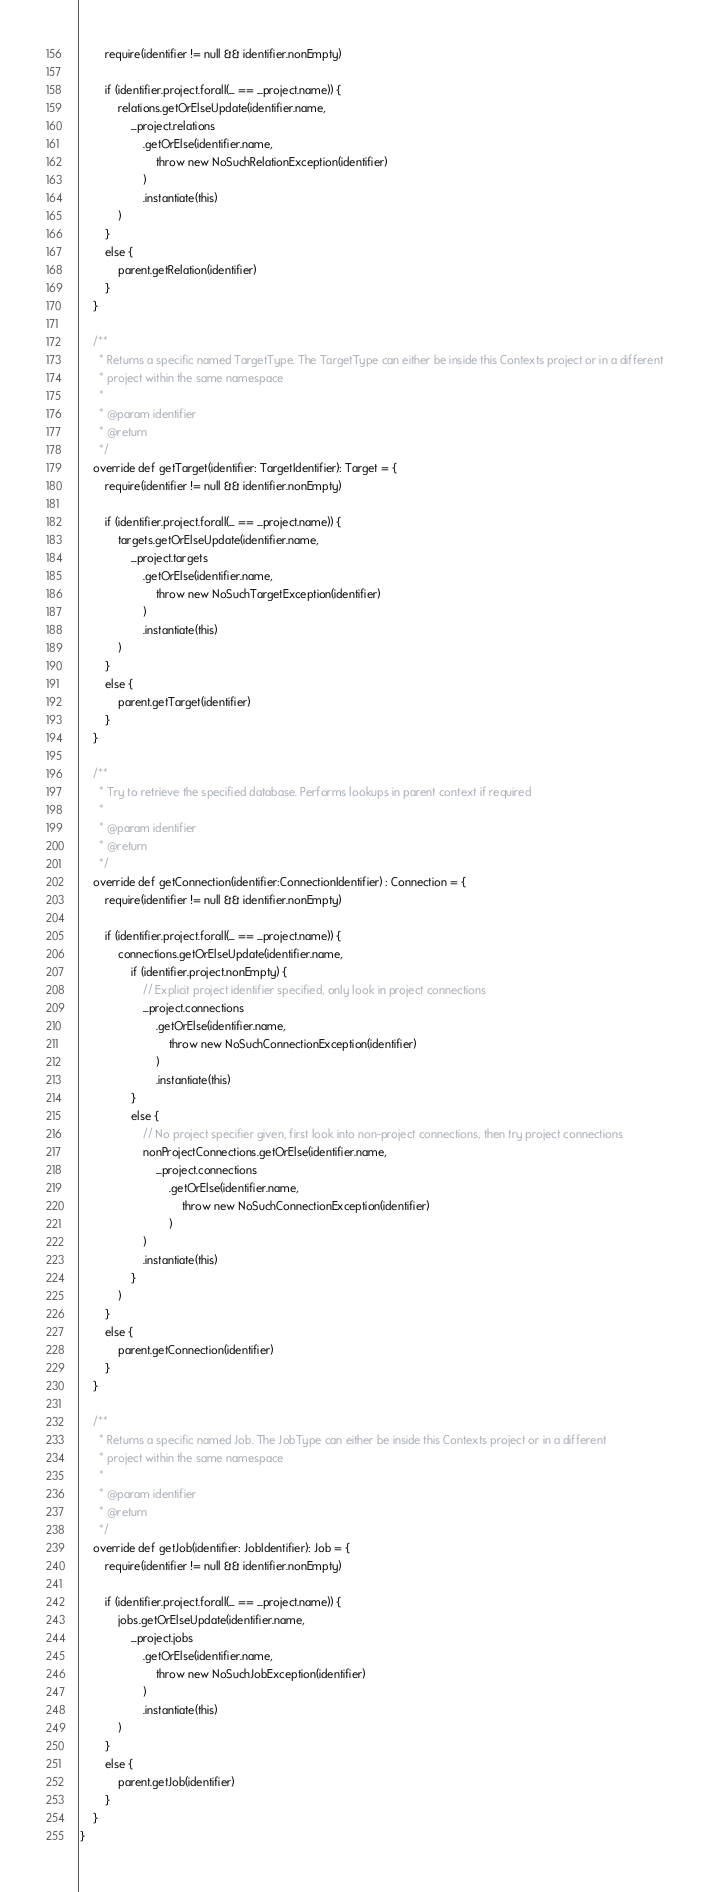Convert code to text. <code><loc_0><loc_0><loc_500><loc_500><_Scala_>        require(identifier != null && identifier.nonEmpty)

        if (identifier.project.forall(_ == _project.name)) {
            relations.getOrElseUpdate(identifier.name,
                _project.relations
                    .getOrElse(identifier.name,
                        throw new NoSuchRelationException(identifier)
                    )
                    .instantiate(this)
            )
        }
        else {
            parent.getRelation(identifier)
        }
    }

    /**
      * Returns a specific named TargetType. The TargetType can either be inside this Contexts project or in a different
      * project within the same namespace
      *
      * @param identifier
      * @return
      */
    override def getTarget(identifier: TargetIdentifier): Target = {
        require(identifier != null && identifier.nonEmpty)

        if (identifier.project.forall(_ == _project.name)) {
            targets.getOrElseUpdate(identifier.name,
                _project.targets
                    .getOrElse(identifier.name,
                        throw new NoSuchTargetException(identifier)
                    )
                    .instantiate(this)
            )
        }
        else {
            parent.getTarget(identifier)
        }
    }

    /**
      * Try to retrieve the specified database. Performs lookups in parent context if required
      *
      * @param identifier
      * @return
      */
    override def getConnection(identifier:ConnectionIdentifier) : Connection = {
        require(identifier != null && identifier.nonEmpty)

        if (identifier.project.forall(_ == _project.name)) {
            connections.getOrElseUpdate(identifier.name,
                if (identifier.project.nonEmpty) {
                    // Explicit project identifier specified, only look in project connections
                    _project.connections
                        .getOrElse(identifier.name,
                            throw new NoSuchConnectionException(identifier)
                        )
                        .instantiate(this)
                }
                else {
                    // No project specifier given, first look into non-project connections, then try project connections
                    nonProjectConnections.getOrElse(identifier.name,
                        _project.connections
                            .getOrElse(identifier.name,
                                throw new NoSuchConnectionException(identifier)
                            )
                    )
                    .instantiate(this)
                }
            )
        }
        else {
            parent.getConnection(identifier)
        }
    }

    /**
      * Returns a specific named Job. The JobType can either be inside this Contexts project or in a different
      * project within the same namespace
      *
      * @param identifier
      * @return
      */
    override def getJob(identifier: JobIdentifier): Job = {
        require(identifier != null && identifier.nonEmpty)

        if (identifier.project.forall(_ == _project.name)) {
            jobs.getOrElseUpdate(identifier.name,
                _project.jobs
                    .getOrElse(identifier.name,
                        throw new NoSuchJobException(identifier)
                    )
                    .instantiate(this)
            )
        }
        else {
            parent.getJob(identifier)
        }
    }
}
</code> 